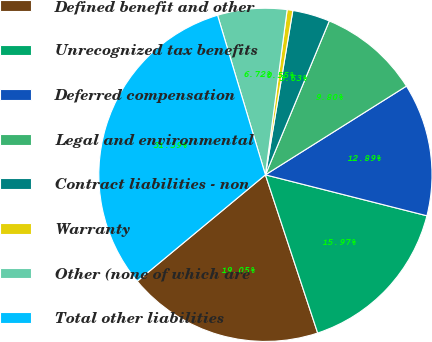<chart> <loc_0><loc_0><loc_500><loc_500><pie_chart><fcel>Defined benefit and other<fcel>Unrecognized tax benefits<fcel>Deferred compensation<fcel>Legal and environmental<fcel>Contract liabilities - non<fcel>Warranty<fcel>Other (none of which are<fcel>Total other liabilities<nl><fcel>19.05%<fcel>15.97%<fcel>12.89%<fcel>9.8%<fcel>3.63%<fcel>0.55%<fcel>6.72%<fcel>31.39%<nl></chart> 